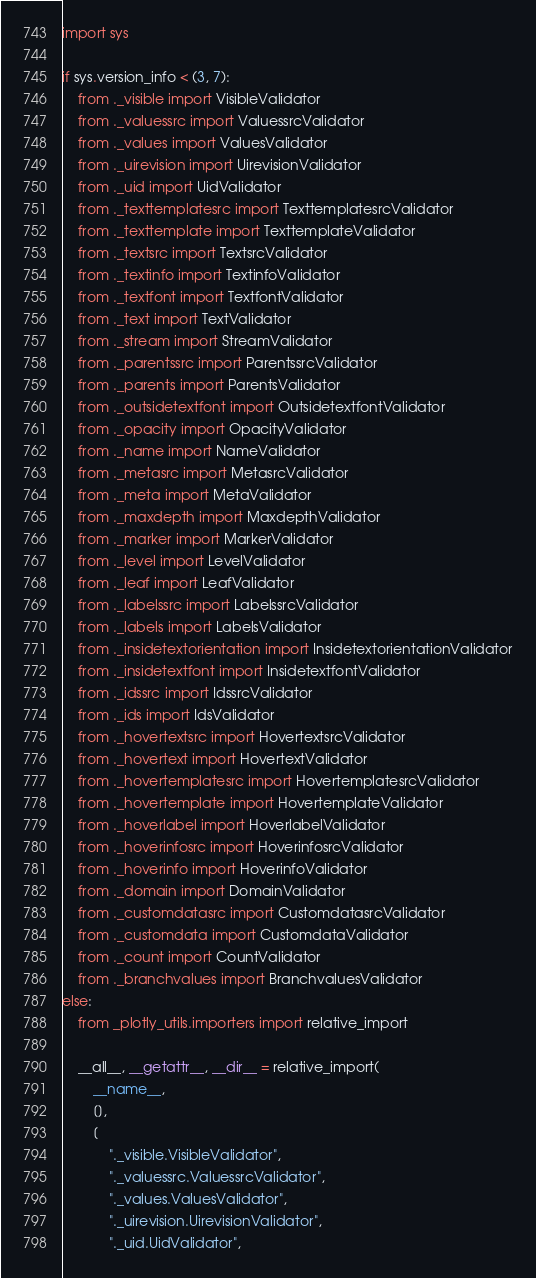<code> <loc_0><loc_0><loc_500><loc_500><_Python_>import sys

if sys.version_info < (3, 7):
    from ._visible import VisibleValidator
    from ._valuessrc import ValuessrcValidator
    from ._values import ValuesValidator
    from ._uirevision import UirevisionValidator
    from ._uid import UidValidator
    from ._texttemplatesrc import TexttemplatesrcValidator
    from ._texttemplate import TexttemplateValidator
    from ._textsrc import TextsrcValidator
    from ._textinfo import TextinfoValidator
    from ._textfont import TextfontValidator
    from ._text import TextValidator
    from ._stream import StreamValidator
    from ._parentssrc import ParentssrcValidator
    from ._parents import ParentsValidator
    from ._outsidetextfont import OutsidetextfontValidator
    from ._opacity import OpacityValidator
    from ._name import NameValidator
    from ._metasrc import MetasrcValidator
    from ._meta import MetaValidator
    from ._maxdepth import MaxdepthValidator
    from ._marker import MarkerValidator
    from ._level import LevelValidator
    from ._leaf import LeafValidator
    from ._labelssrc import LabelssrcValidator
    from ._labels import LabelsValidator
    from ._insidetextorientation import InsidetextorientationValidator
    from ._insidetextfont import InsidetextfontValidator
    from ._idssrc import IdssrcValidator
    from ._ids import IdsValidator
    from ._hovertextsrc import HovertextsrcValidator
    from ._hovertext import HovertextValidator
    from ._hovertemplatesrc import HovertemplatesrcValidator
    from ._hovertemplate import HovertemplateValidator
    from ._hoverlabel import HoverlabelValidator
    from ._hoverinfosrc import HoverinfosrcValidator
    from ._hoverinfo import HoverinfoValidator
    from ._domain import DomainValidator
    from ._customdatasrc import CustomdatasrcValidator
    from ._customdata import CustomdataValidator
    from ._count import CountValidator
    from ._branchvalues import BranchvaluesValidator
else:
    from _plotly_utils.importers import relative_import

    __all__, __getattr__, __dir__ = relative_import(
        __name__,
        [],
        [
            "._visible.VisibleValidator",
            "._valuessrc.ValuessrcValidator",
            "._values.ValuesValidator",
            "._uirevision.UirevisionValidator",
            "._uid.UidValidator",</code> 